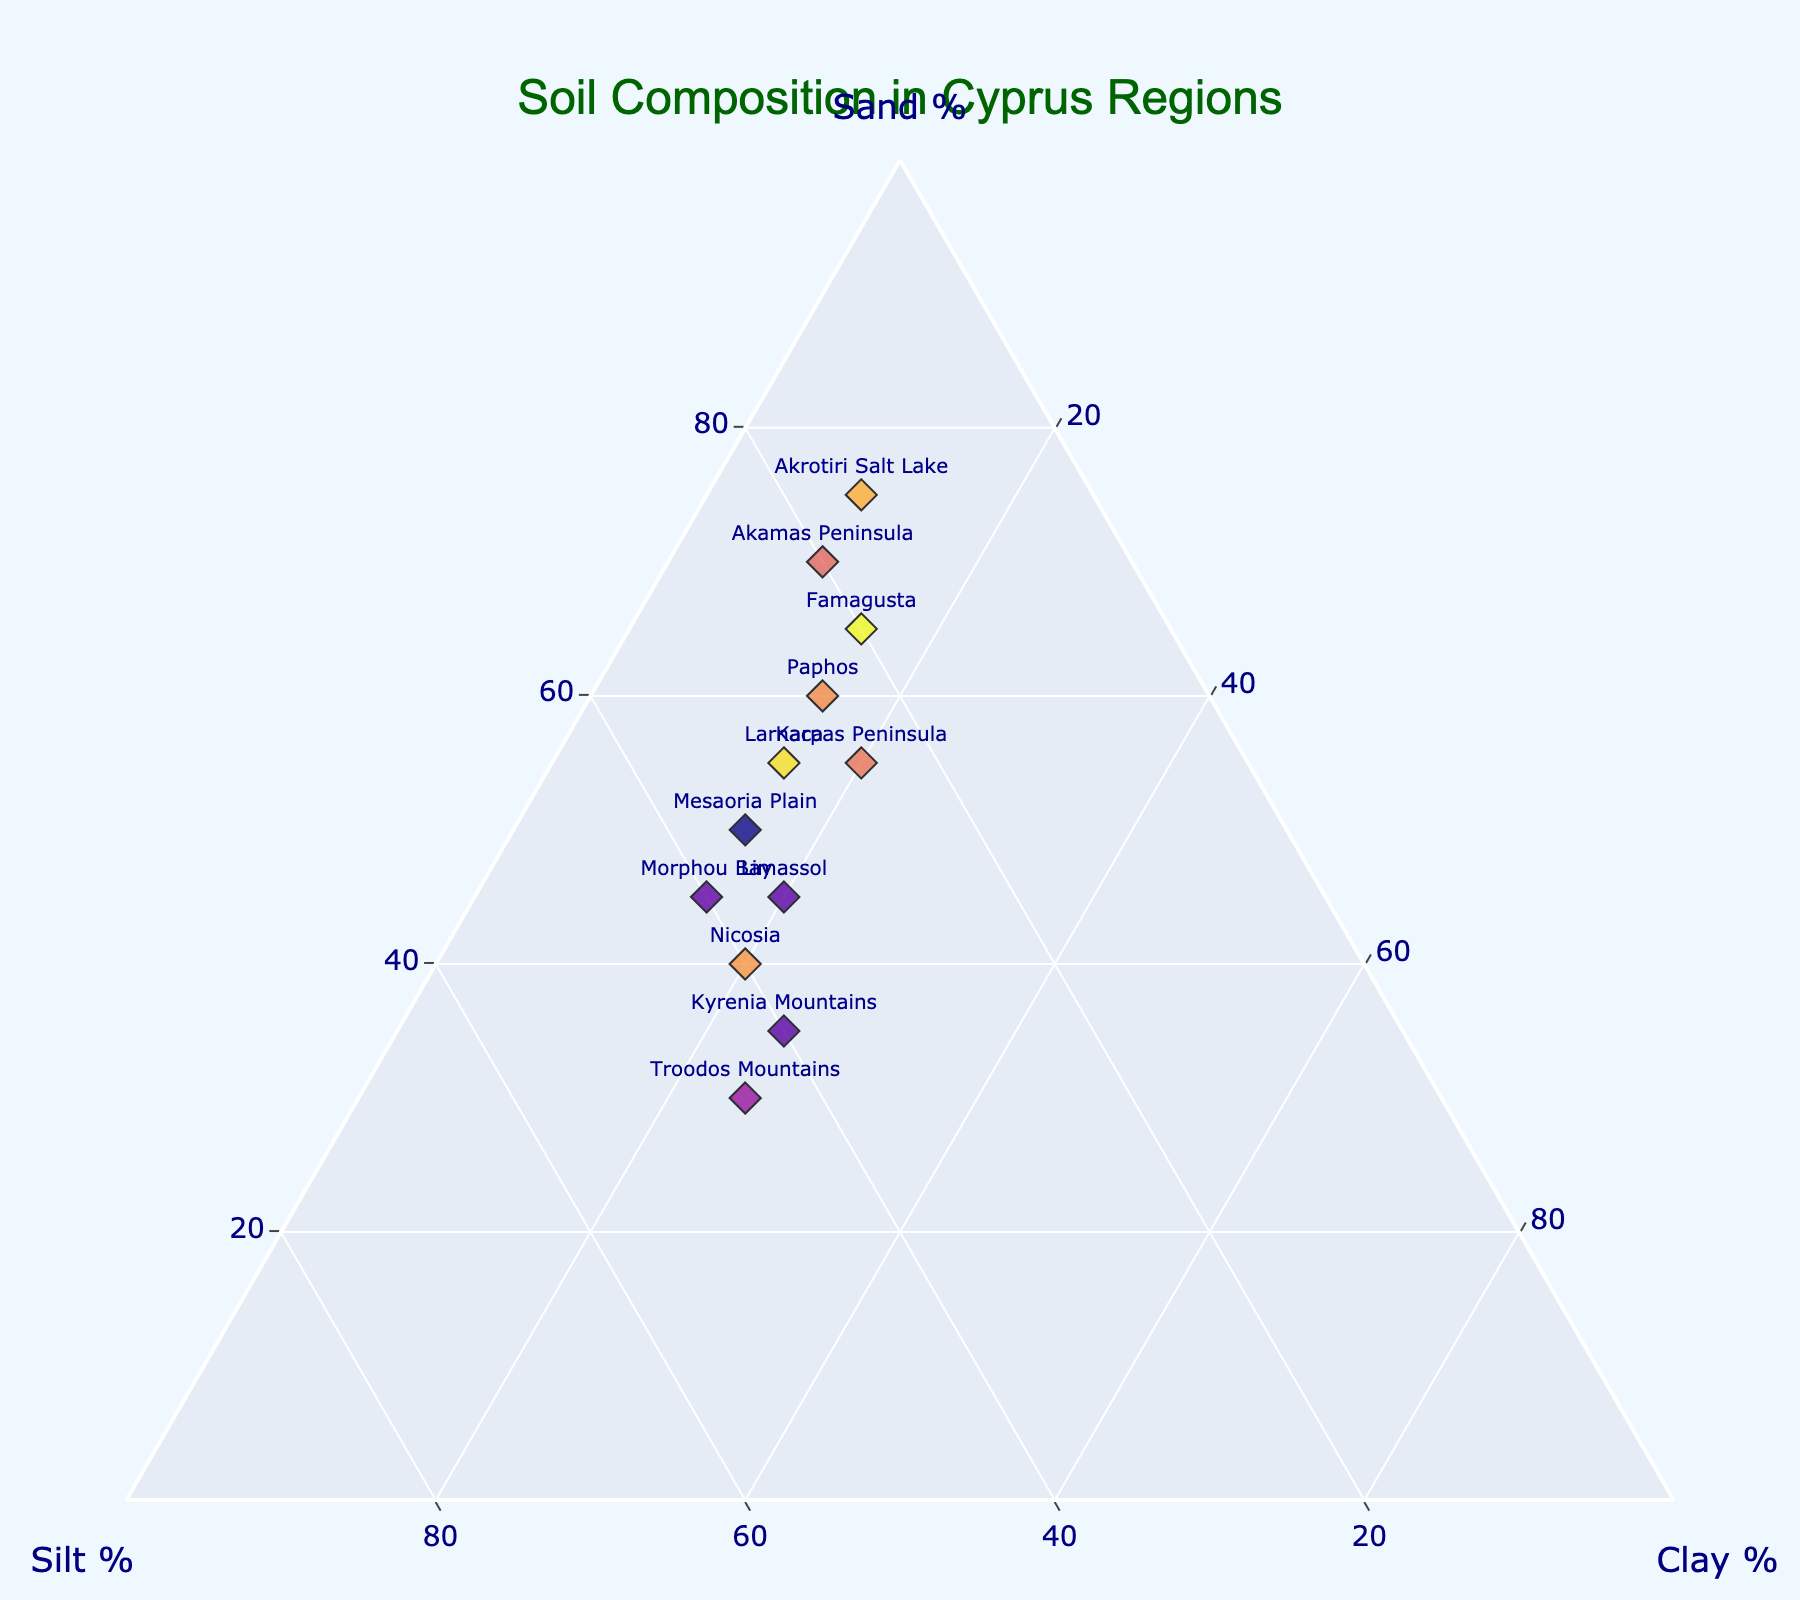What is the title of the ternary plot? The title is found at the top of the plot, typically centered and in larger font
Answer: Soil Composition in Cyprus Regions Which region has the highest percentage of sand? Locate the point on the ternary plot closest to the "Sand %" axis, which represents the region with the highest sand content
Answer: Akrotiri Salt Lake Compare the sand percentage in Larnaca and Morphou Bay. Which one is higher? Look for the points labeled "Larnaca" and "Morphou Bay" and compare their positions relative to the "Sand %" axis
Answer: Larnaca Which region shows the highest proportion of clay? Find the point on the ternary plot closest to the "Clay %" axis, indicating the region with the highest clay content
Answer: Kyrenia Mountains Which two regions share the same clay percentage? Identify regions with points aligned horizontally with equal distances from the "Clay %" axis
Answer: Paphos, Famagusta, and Larnaca What is the average percentage of sand for Nicosia and Limassol? Add the sand percentages of Nicosia (40%) and Limassol (45%) and then divide by 2 to find the average
Answer: (40 + 45)/2 = 42.5 Which region has the most balanced composition of sand, silt, and clay? Look for a point near the center of the ternary plot, where all three components are evenly distributed
Answer: Troodos Mountains Compare the silt percentages in Akamas Peninsula and Troodos Mountains. Which one has more silt? Locate the points for Akamas Peninsula (20%) and Troodos Mountains (45%), then compare their positions on the "Silt %" axis
Answer: Troodos Mountains How many regions contain between 20% and 40% clay? Count the number of points that fall between the 20% and 40% lines on the "Clay %" axis
Answer: Three regions (Nicosia, Troodos Mountains, Kyrenia Mountains) Of the regions with the top three highest percentages of sand, which one has the lowest percentage of clay? Identify the top three regions with the highest sand percentages (Akrotiri Salt Lake, Akamas Peninsula, Famagusta) and compare their clay percentages
Answer: Akrotiri Salt Lake 